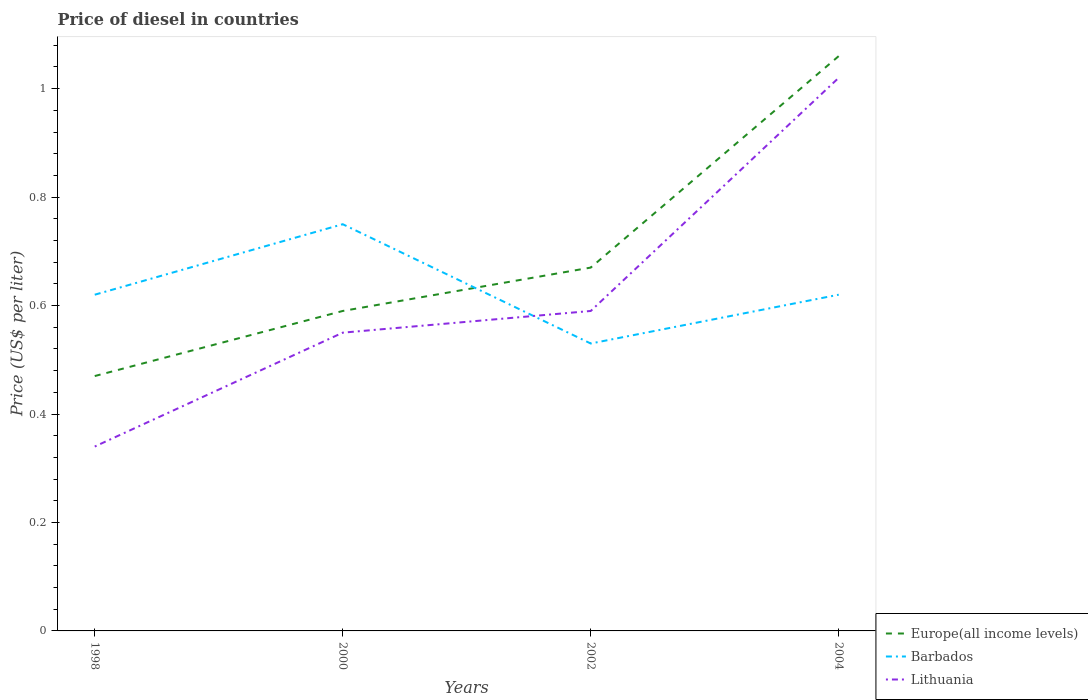How many different coloured lines are there?
Keep it short and to the point. 3. Is the number of lines equal to the number of legend labels?
Give a very brief answer. Yes. Across all years, what is the maximum price of diesel in Lithuania?
Offer a very short reply. 0.34. What is the total price of diesel in Europe(all income levels) in the graph?
Your answer should be compact. -0.59. What is the difference between the highest and the second highest price of diesel in Europe(all income levels)?
Your answer should be very brief. 0.59. What is the difference between the highest and the lowest price of diesel in Barbados?
Give a very brief answer. 1. How many years are there in the graph?
Provide a short and direct response. 4. What is the difference between two consecutive major ticks on the Y-axis?
Your response must be concise. 0.2. Are the values on the major ticks of Y-axis written in scientific E-notation?
Make the answer very short. No. How many legend labels are there?
Your answer should be very brief. 3. What is the title of the graph?
Ensure brevity in your answer.  Price of diesel in countries. What is the label or title of the X-axis?
Offer a very short reply. Years. What is the label or title of the Y-axis?
Your answer should be compact. Price (US$ per liter). What is the Price (US$ per liter) in Europe(all income levels) in 1998?
Your answer should be very brief. 0.47. What is the Price (US$ per liter) of Barbados in 1998?
Make the answer very short. 0.62. What is the Price (US$ per liter) in Lithuania in 1998?
Your answer should be very brief. 0.34. What is the Price (US$ per liter) in Europe(all income levels) in 2000?
Your answer should be compact. 0.59. What is the Price (US$ per liter) of Barbados in 2000?
Offer a very short reply. 0.75. What is the Price (US$ per liter) in Lithuania in 2000?
Give a very brief answer. 0.55. What is the Price (US$ per liter) in Europe(all income levels) in 2002?
Make the answer very short. 0.67. What is the Price (US$ per liter) of Barbados in 2002?
Keep it short and to the point. 0.53. What is the Price (US$ per liter) of Lithuania in 2002?
Give a very brief answer. 0.59. What is the Price (US$ per liter) of Europe(all income levels) in 2004?
Offer a very short reply. 1.06. What is the Price (US$ per liter) in Barbados in 2004?
Your response must be concise. 0.62. Across all years, what is the maximum Price (US$ per liter) of Europe(all income levels)?
Provide a short and direct response. 1.06. Across all years, what is the minimum Price (US$ per liter) of Europe(all income levels)?
Your response must be concise. 0.47. Across all years, what is the minimum Price (US$ per liter) of Barbados?
Ensure brevity in your answer.  0.53. Across all years, what is the minimum Price (US$ per liter) in Lithuania?
Your response must be concise. 0.34. What is the total Price (US$ per liter) of Europe(all income levels) in the graph?
Ensure brevity in your answer.  2.79. What is the total Price (US$ per liter) of Barbados in the graph?
Make the answer very short. 2.52. What is the total Price (US$ per liter) of Lithuania in the graph?
Give a very brief answer. 2.5. What is the difference between the Price (US$ per liter) of Europe(all income levels) in 1998 and that in 2000?
Offer a very short reply. -0.12. What is the difference between the Price (US$ per liter) of Barbados in 1998 and that in 2000?
Provide a succinct answer. -0.13. What is the difference between the Price (US$ per liter) of Lithuania in 1998 and that in 2000?
Ensure brevity in your answer.  -0.21. What is the difference between the Price (US$ per liter) of Barbados in 1998 and that in 2002?
Provide a succinct answer. 0.09. What is the difference between the Price (US$ per liter) in Lithuania in 1998 and that in 2002?
Provide a succinct answer. -0.25. What is the difference between the Price (US$ per liter) in Europe(all income levels) in 1998 and that in 2004?
Your answer should be very brief. -0.59. What is the difference between the Price (US$ per liter) in Lithuania in 1998 and that in 2004?
Give a very brief answer. -0.68. What is the difference between the Price (US$ per liter) of Europe(all income levels) in 2000 and that in 2002?
Your answer should be compact. -0.08. What is the difference between the Price (US$ per liter) in Barbados in 2000 and that in 2002?
Make the answer very short. 0.22. What is the difference between the Price (US$ per liter) of Lithuania in 2000 and that in 2002?
Your answer should be very brief. -0.04. What is the difference between the Price (US$ per liter) of Europe(all income levels) in 2000 and that in 2004?
Your response must be concise. -0.47. What is the difference between the Price (US$ per liter) of Barbados in 2000 and that in 2004?
Your response must be concise. 0.13. What is the difference between the Price (US$ per liter) in Lithuania in 2000 and that in 2004?
Your response must be concise. -0.47. What is the difference between the Price (US$ per liter) of Europe(all income levels) in 2002 and that in 2004?
Keep it short and to the point. -0.39. What is the difference between the Price (US$ per liter) of Barbados in 2002 and that in 2004?
Your answer should be very brief. -0.09. What is the difference between the Price (US$ per liter) in Lithuania in 2002 and that in 2004?
Your answer should be very brief. -0.43. What is the difference between the Price (US$ per liter) of Europe(all income levels) in 1998 and the Price (US$ per liter) of Barbados in 2000?
Make the answer very short. -0.28. What is the difference between the Price (US$ per liter) of Europe(all income levels) in 1998 and the Price (US$ per liter) of Lithuania in 2000?
Make the answer very short. -0.08. What is the difference between the Price (US$ per liter) in Barbados in 1998 and the Price (US$ per liter) in Lithuania in 2000?
Give a very brief answer. 0.07. What is the difference between the Price (US$ per liter) of Europe(all income levels) in 1998 and the Price (US$ per liter) of Barbados in 2002?
Make the answer very short. -0.06. What is the difference between the Price (US$ per liter) in Europe(all income levels) in 1998 and the Price (US$ per liter) in Lithuania in 2002?
Offer a very short reply. -0.12. What is the difference between the Price (US$ per liter) in Europe(all income levels) in 1998 and the Price (US$ per liter) in Barbados in 2004?
Offer a terse response. -0.15. What is the difference between the Price (US$ per liter) of Europe(all income levels) in 1998 and the Price (US$ per liter) of Lithuania in 2004?
Keep it short and to the point. -0.55. What is the difference between the Price (US$ per liter) of Europe(all income levels) in 2000 and the Price (US$ per liter) of Barbados in 2002?
Your answer should be compact. 0.06. What is the difference between the Price (US$ per liter) in Europe(all income levels) in 2000 and the Price (US$ per liter) in Lithuania in 2002?
Provide a succinct answer. 0. What is the difference between the Price (US$ per liter) of Barbados in 2000 and the Price (US$ per liter) of Lithuania in 2002?
Your response must be concise. 0.16. What is the difference between the Price (US$ per liter) in Europe(all income levels) in 2000 and the Price (US$ per liter) in Barbados in 2004?
Your answer should be compact. -0.03. What is the difference between the Price (US$ per liter) in Europe(all income levels) in 2000 and the Price (US$ per liter) in Lithuania in 2004?
Make the answer very short. -0.43. What is the difference between the Price (US$ per liter) in Barbados in 2000 and the Price (US$ per liter) in Lithuania in 2004?
Make the answer very short. -0.27. What is the difference between the Price (US$ per liter) of Europe(all income levels) in 2002 and the Price (US$ per liter) of Lithuania in 2004?
Offer a very short reply. -0.35. What is the difference between the Price (US$ per liter) in Barbados in 2002 and the Price (US$ per liter) in Lithuania in 2004?
Your answer should be compact. -0.49. What is the average Price (US$ per liter) of Europe(all income levels) per year?
Your answer should be very brief. 0.7. What is the average Price (US$ per liter) of Barbados per year?
Give a very brief answer. 0.63. What is the average Price (US$ per liter) in Lithuania per year?
Ensure brevity in your answer.  0.62. In the year 1998, what is the difference between the Price (US$ per liter) in Europe(all income levels) and Price (US$ per liter) in Barbados?
Your answer should be compact. -0.15. In the year 1998, what is the difference between the Price (US$ per liter) in Europe(all income levels) and Price (US$ per liter) in Lithuania?
Provide a succinct answer. 0.13. In the year 1998, what is the difference between the Price (US$ per liter) of Barbados and Price (US$ per liter) of Lithuania?
Your response must be concise. 0.28. In the year 2000, what is the difference between the Price (US$ per liter) of Europe(all income levels) and Price (US$ per liter) of Barbados?
Your answer should be compact. -0.16. In the year 2000, what is the difference between the Price (US$ per liter) of Europe(all income levels) and Price (US$ per liter) of Lithuania?
Your answer should be compact. 0.04. In the year 2002, what is the difference between the Price (US$ per liter) of Europe(all income levels) and Price (US$ per liter) of Barbados?
Make the answer very short. 0.14. In the year 2002, what is the difference between the Price (US$ per liter) in Europe(all income levels) and Price (US$ per liter) in Lithuania?
Give a very brief answer. 0.08. In the year 2002, what is the difference between the Price (US$ per liter) in Barbados and Price (US$ per liter) in Lithuania?
Your response must be concise. -0.06. In the year 2004, what is the difference between the Price (US$ per liter) in Europe(all income levels) and Price (US$ per liter) in Barbados?
Your answer should be very brief. 0.44. In the year 2004, what is the difference between the Price (US$ per liter) in Europe(all income levels) and Price (US$ per liter) in Lithuania?
Give a very brief answer. 0.04. What is the ratio of the Price (US$ per liter) of Europe(all income levels) in 1998 to that in 2000?
Keep it short and to the point. 0.8. What is the ratio of the Price (US$ per liter) in Barbados in 1998 to that in 2000?
Offer a very short reply. 0.83. What is the ratio of the Price (US$ per liter) of Lithuania in 1998 to that in 2000?
Provide a succinct answer. 0.62. What is the ratio of the Price (US$ per liter) in Europe(all income levels) in 1998 to that in 2002?
Ensure brevity in your answer.  0.7. What is the ratio of the Price (US$ per liter) in Barbados in 1998 to that in 2002?
Your answer should be compact. 1.17. What is the ratio of the Price (US$ per liter) in Lithuania in 1998 to that in 2002?
Provide a succinct answer. 0.58. What is the ratio of the Price (US$ per liter) in Europe(all income levels) in 1998 to that in 2004?
Keep it short and to the point. 0.44. What is the ratio of the Price (US$ per liter) in Barbados in 1998 to that in 2004?
Offer a very short reply. 1. What is the ratio of the Price (US$ per liter) in Europe(all income levels) in 2000 to that in 2002?
Offer a terse response. 0.88. What is the ratio of the Price (US$ per liter) of Barbados in 2000 to that in 2002?
Your answer should be very brief. 1.42. What is the ratio of the Price (US$ per liter) in Lithuania in 2000 to that in 2002?
Your response must be concise. 0.93. What is the ratio of the Price (US$ per liter) of Europe(all income levels) in 2000 to that in 2004?
Keep it short and to the point. 0.56. What is the ratio of the Price (US$ per liter) in Barbados in 2000 to that in 2004?
Provide a short and direct response. 1.21. What is the ratio of the Price (US$ per liter) in Lithuania in 2000 to that in 2004?
Your response must be concise. 0.54. What is the ratio of the Price (US$ per liter) of Europe(all income levels) in 2002 to that in 2004?
Your answer should be very brief. 0.63. What is the ratio of the Price (US$ per liter) of Barbados in 2002 to that in 2004?
Your answer should be compact. 0.85. What is the ratio of the Price (US$ per liter) of Lithuania in 2002 to that in 2004?
Keep it short and to the point. 0.58. What is the difference between the highest and the second highest Price (US$ per liter) in Europe(all income levels)?
Your answer should be very brief. 0.39. What is the difference between the highest and the second highest Price (US$ per liter) of Barbados?
Keep it short and to the point. 0.13. What is the difference between the highest and the second highest Price (US$ per liter) of Lithuania?
Keep it short and to the point. 0.43. What is the difference between the highest and the lowest Price (US$ per liter) of Europe(all income levels)?
Ensure brevity in your answer.  0.59. What is the difference between the highest and the lowest Price (US$ per liter) of Barbados?
Make the answer very short. 0.22. What is the difference between the highest and the lowest Price (US$ per liter) of Lithuania?
Give a very brief answer. 0.68. 